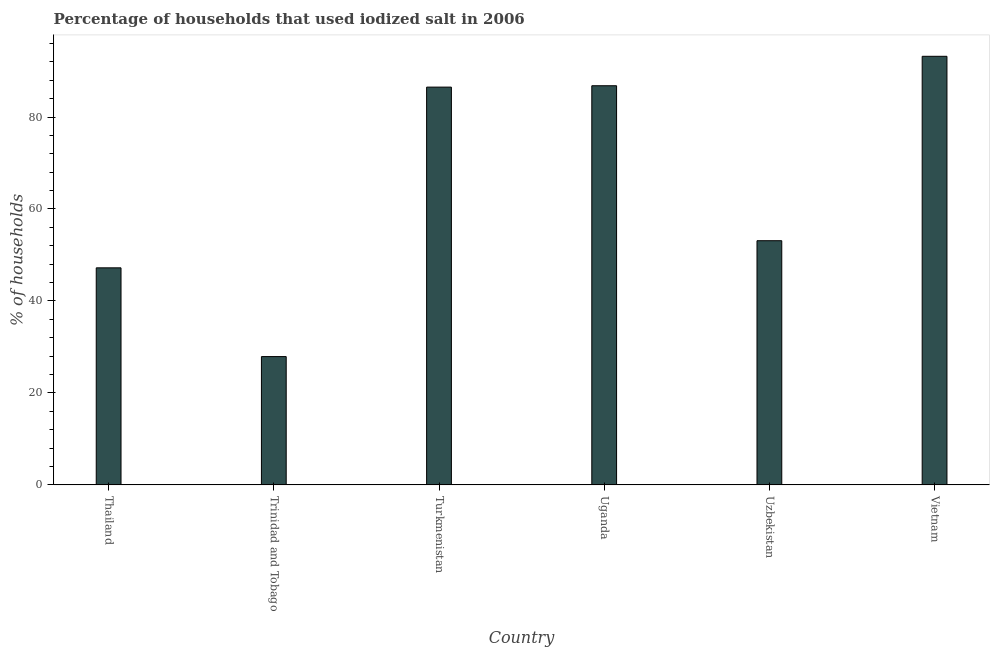Does the graph contain any zero values?
Make the answer very short. No. Does the graph contain grids?
Ensure brevity in your answer.  No. What is the title of the graph?
Your response must be concise. Percentage of households that used iodized salt in 2006. What is the label or title of the X-axis?
Your answer should be very brief. Country. What is the label or title of the Y-axis?
Provide a short and direct response. % of households. What is the percentage of households where iodized salt is consumed in Trinidad and Tobago?
Your answer should be compact. 27.9. Across all countries, what is the maximum percentage of households where iodized salt is consumed?
Make the answer very short. 93.2. Across all countries, what is the minimum percentage of households where iodized salt is consumed?
Offer a very short reply. 27.9. In which country was the percentage of households where iodized salt is consumed maximum?
Your response must be concise. Vietnam. In which country was the percentage of households where iodized salt is consumed minimum?
Give a very brief answer. Trinidad and Tobago. What is the sum of the percentage of households where iodized salt is consumed?
Keep it short and to the point. 394.7. What is the difference between the percentage of households where iodized salt is consumed in Turkmenistan and Uzbekistan?
Offer a very short reply. 33.4. What is the average percentage of households where iodized salt is consumed per country?
Provide a succinct answer. 65.78. What is the median percentage of households where iodized salt is consumed?
Make the answer very short. 69.8. What is the ratio of the percentage of households where iodized salt is consumed in Thailand to that in Vietnam?
Give a very brief answer. 0.51. Is the percentage of households where iodized salt is consumed in Turkmenistan less than that in Vietnam?
Offer a terse response. Yes. What is the difference between the highest and the second highest percentage of households where iodized salt is consumed?
Ensure brevity in your answer.  6.4. Is the sum of the percentage of households where iodized salt is consumed in Trinidad and Tobago and Vietnam greater than the maximum percentage of households where iodized salt is consumed across all countries?
Make the answer very short. Yes. What is the difference between the highest and the lowest percentage of households where iodized salt is consumed?
Your answer should be very brief. 65.3. How many bars are there?
Your answer should be very brief. 6. Are all the bars in the graph horizontal?
Your response must be concise. No. How many countries are there in the graph?
Your response must be concise. 6. What is the difference between two consecutive major ticks on the Y-axis?
Your answer should be very brief. 20. What is the % of households in Thailand?
Make the answer very short. 47.2. What is the % of households in Trinidad and Tobago?
Provide a succinct answer. 27.9. What is the % of households of Turkmenistan?
Keep it short and to the point. 86.5. What is the % of households in Uganda?
Provide a short and direct response. 86.8. What is the % of households of Uzbekistan?
Make the answer very short. 53.1. What is the % of households of Vietnam?
Provide a succinct answer. 93.2. What is the difference between the % of households in Thailand and Trinidad and Tobago?
Keep it short and to the point. 19.3. What is the difference between the % of households in Thailand and Turkmenistan?
Keep it short and to the point. -39.3. What is the difference between the % of households in Thailand and Uganda?
Provide a short and direct response. -39.6. What is the difference between the % of households in Thailand and Uzbekistan?
Offer a very short reply. -5.9. What is the difference between the % of households in Thailand and Vietnam?
Your answer should be compact. -46. What is the difference between the % of households in Trinidad and Tobago and Turkmenistan?
Offer a terse response. -58.6. What is the difference between the % of households in Trinidad and Tobago and Uganda?
Your answer should be very brief. -58.9. What is the difference between the % of households in Trinidad and Tobago and Uzbekistan?
Your answer should be compact. -25.2. What is the difference between the % of households in Trinidad and Tobago and Vietnam?
Give a very brief answer. -65.3. What is the difference between the % of households in Turkmenistan and Uganda?
Your answer should be compact. -0.3. What is the difference between the % of households in Turkmenistan and Uzbekistan?
Your response must be concise. 33.4. What is the difference between the % of households in Turkmenistan and Vietnam?
Make the answer very short. -6.7. What is the difference between the % of households in Uganda and Uzbekistan?
Your answer should be compact. 33.7. What is the difference between the % of households in Uzbekistan and Vietnam?
Give a very brief answer. -40.1. What is the ratio of the % of households in Thailand to that in Trinidad and Tobago?
Your answer should be very brief. 1.69. What is the ratio of the % of households in Thailand to that in Turkmenistan?
Offer a very short reply. 0.55. What is the ratio of the % of households in Thailand to that in Uganda?
Your answer should be very brief. 0.54. What is the ratio of the % of households in Thailand to that in Uzbekistan?
Provide a short and direct response. 0.89. What is the ratio of the % of households in Thailand to that in Vietnam?
Keep it short and to the point. 0.51. What is the ratio of the % of households in Trinidad and Tobago to that in Turkmenistan?
Ensure brevity in your answer.  0.32. What is the ratio of the % of households in Trinidad and Tobago to that in Uganda?
Your answer should be very brief. 0.32. What is the ratio of the % of households in Trinidad and Tobago to that in Uzbekistan?
Keep it short and to the point. 0.53. What is the ratio of the % of households in Trinidad and Tobago to that in Vietnam?
Offer a terse response. 0.3. What is the ratio of the % of households in Turkmenistan to that in Uzbekistan?
Your response must be concise. 1.63. What is the ratio of the % of households in Turkmenistan to that in Vietnam?
Offer a very short reply. 0.93. What is the ratio of the % of households in Uganda to that in Uzbekistan?
Provide a short and direct response. 1.64. What is the ratio of the % of households in Uganda to that in Vietnam?
Your response must be concise. 0.93. What is the ratio of the % of households in Uzbekistan to that in Vietnam?
Offer a very short reply. 0.57. 